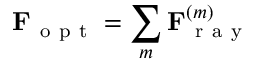<formula> <loc_0><loc_0><loc_500><loc_500>F _ { o p t } = \sum _ { m } F _ { r a y } ^ { ( m ) }</formula> 